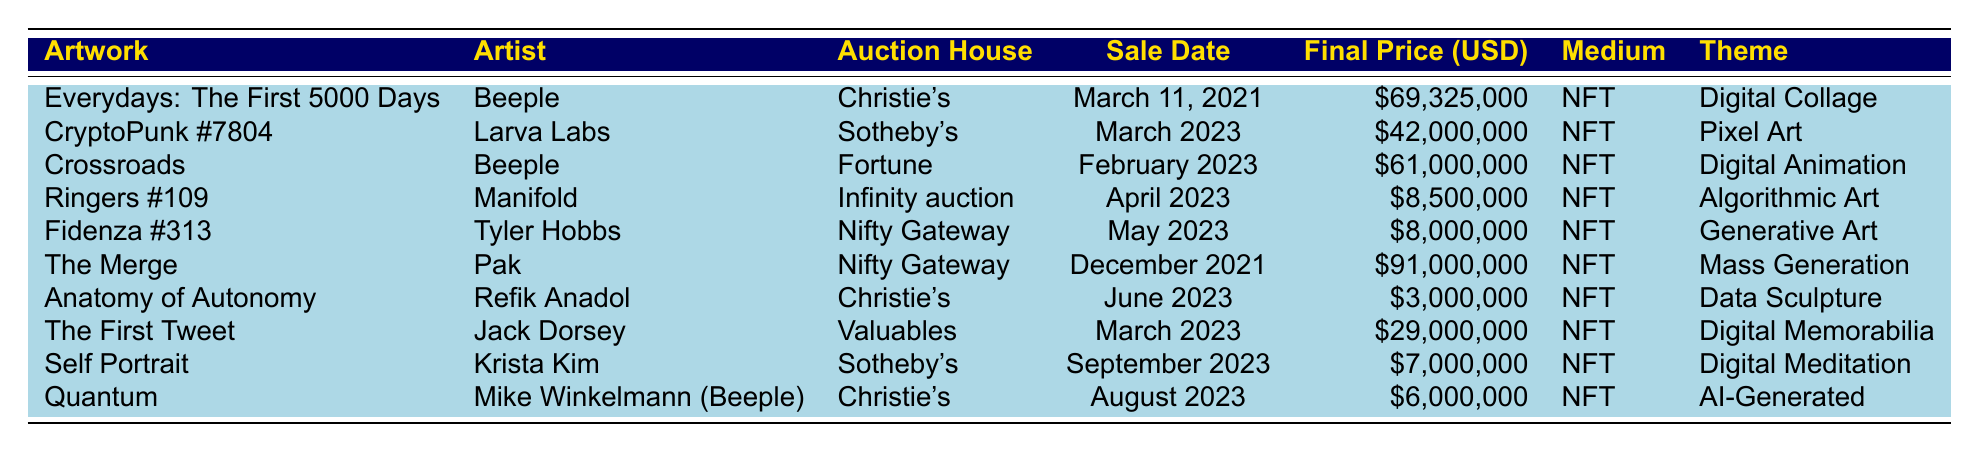What is the highest final price for a digital artwork sold in 2023? The highest final price for a digital artwork sold in 2023, as listed in the table, is $61,000,000 for "Crossroads" by Beeple.
Answer: $61,000,000 What is the total final price of all artworks sold in March 2023? The artworks sold in March 2023 are "CryptoPunk #7804" ($42,000,000) and "The First Tweet" ($29,000,000). Adding these gives $42,000,000 + $29,000,000 = $71,000,000.
Answer: $71,000,000 Which artist had the lowest recorded final price in the table? The artwork with the lowest final price is "Anatomy of Autonomy" by Refik Anadol, which sold for $3,000,000.
Answer: Refik Anadol Is there any artwork sold in 2023 with a final price over $40,000,000? Yes, there are two artworks sold in 2023 that have final prices over $40,000,000: "CryptoPunk #7804" ($42,000,000) and "Crossroads" ($61,000,000).
Answer: Yes What is the average final price of the digital artworks sold in April and May 2023? The final prices for artworks sold in April ($8,500,000) and May ($8,000,000) are added together: $8,500,000 + $8,000,000 = $16,500,000. There are 2 artworks, so the average is $16,500,000 / 2 = $8,250,000.
Answer: $8,250,000 Which auction house sold the artwork "The Merge"? "The Merge" was sold at Nifty Gateway, according to the table.
Answer: Nifty Gateway Is it true that all artworks listed in the table are NFTs? Yes, all the artworks listed in the table specify that they are NFTs in the medium column.
Answer: Yes What is the difference in final price between the highest and lowest priced artworks sold in 2023? The highest priced artwork is "Crossroads" with a final price of $61,000,000, and the lowest is "Anatomy of Autonomy" at $3,000,000. The difference is $61,000,000 - $3,000,000 = $58,000,000.
Answer: $58,000,000 